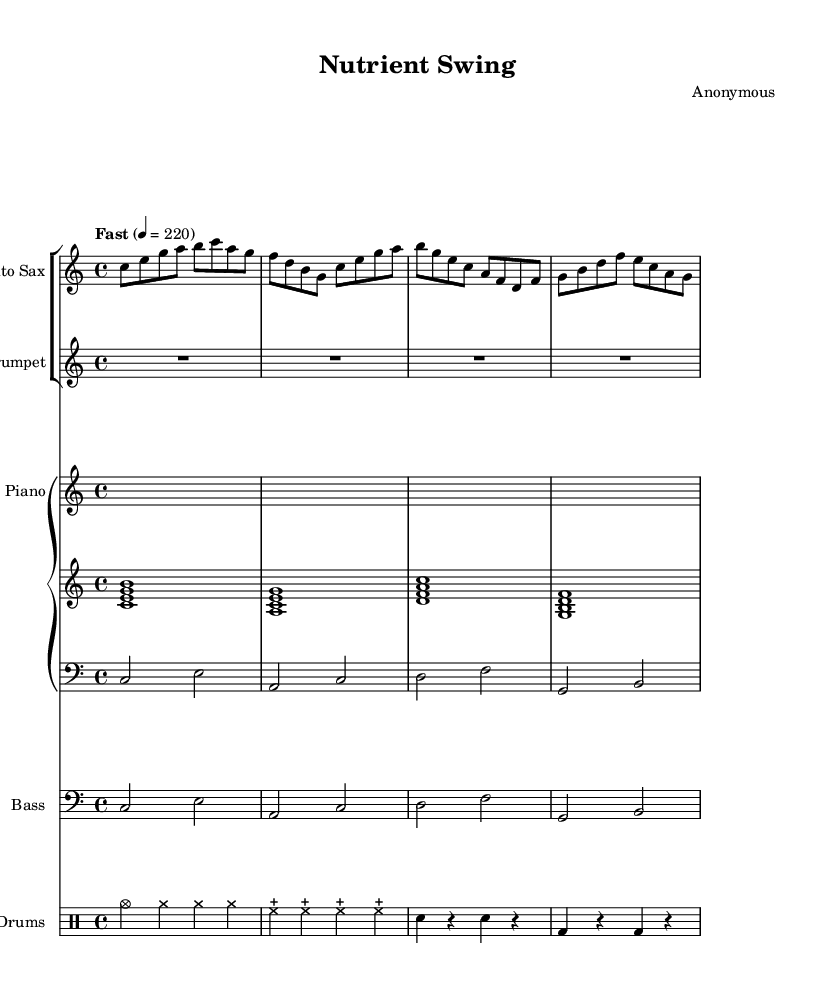What is the key signature of this music? The key signature is indicated at the beginning of the music. In this case, it is C major, which has no sharps or flats.
Answer: C major What is the time signature of this music? The time signature is shown at the beginning of the piece, and in this case, it is 4/4, which means there are four beats per measure.
Answer: 4/4 What is the tempo marking for this composition? The tempo marking is located above the staff and states "Fast" with a metronome marking of 220 beats per minute, indicating a quick pace.
Answer: Fast 4 = 220 How many measures are in the alto saxophone part? By counting the measures presented in the alto saxophone staff, there are four measures outlined in this excerpt.
Answer: 4 What is the instrument labeled for the second staff in the score? The second staff group listed specifies the instrument as "Trumpet," which can be seen at the beginning of the staff.
Answer: Trumpet What type of rhythm is predominantly used in the drums section? The drums section predominantly utilizes a swing rhythm, characterized by a consistent pattern of cymbals and bass drum hits followed by snare accents, which is typical of jazz.
Answer: Swing How does the bass line relate to the chord structure indicated in the piano part? The bass line mirrors the chord structure played by the piano, following the same root notes and providing harmonic support, which is a common practice in jazz arrangements.
Answer: Harmonically supportive 